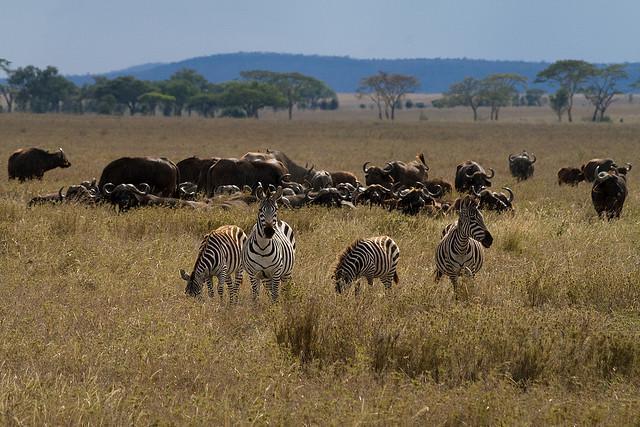How many zebras are standing in front of the pack of buffalo?
Indicate the correct choice and explain in the format: 'Answer: answer
Rationale: rationale.'
Options: Three, four, five, two. Answer: four.
Rationale: There are four zebras. 